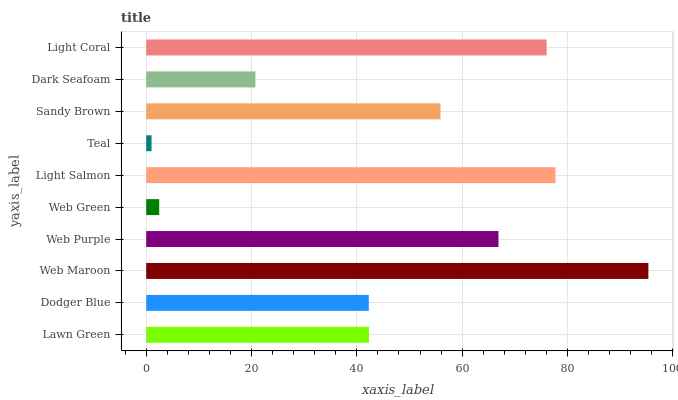Is Teal the minimum?
Answer yes or no. Yes. Is Web Maroon the maximum?
Answer yes or no. Yes. Is Dodger Blue the minimum?
Answer yes or no. No. Is Dodger Blue the maximum?
Answer yes or no. No. Is Lawn Green greater than Dodger Blue?
Answer yes or no. Yes. Is Dodger Blue less than Lawn Green?
Answer yes or no. Yes. Is Dodger Blue greater than Lawn Green?
Answer yes or no. No. Is Lawn Green less than Dodger Blue?
Answer yes or no. No. Is Sandy Brown the high median?
Answer yes or no. Yes. Is Lawn Green the low median?
Answer yes or no. Yes. Is Dark Seafoam the high median?
Answer yes or no. No. Is Web Purple the low median?
Answer yes or no. No. 